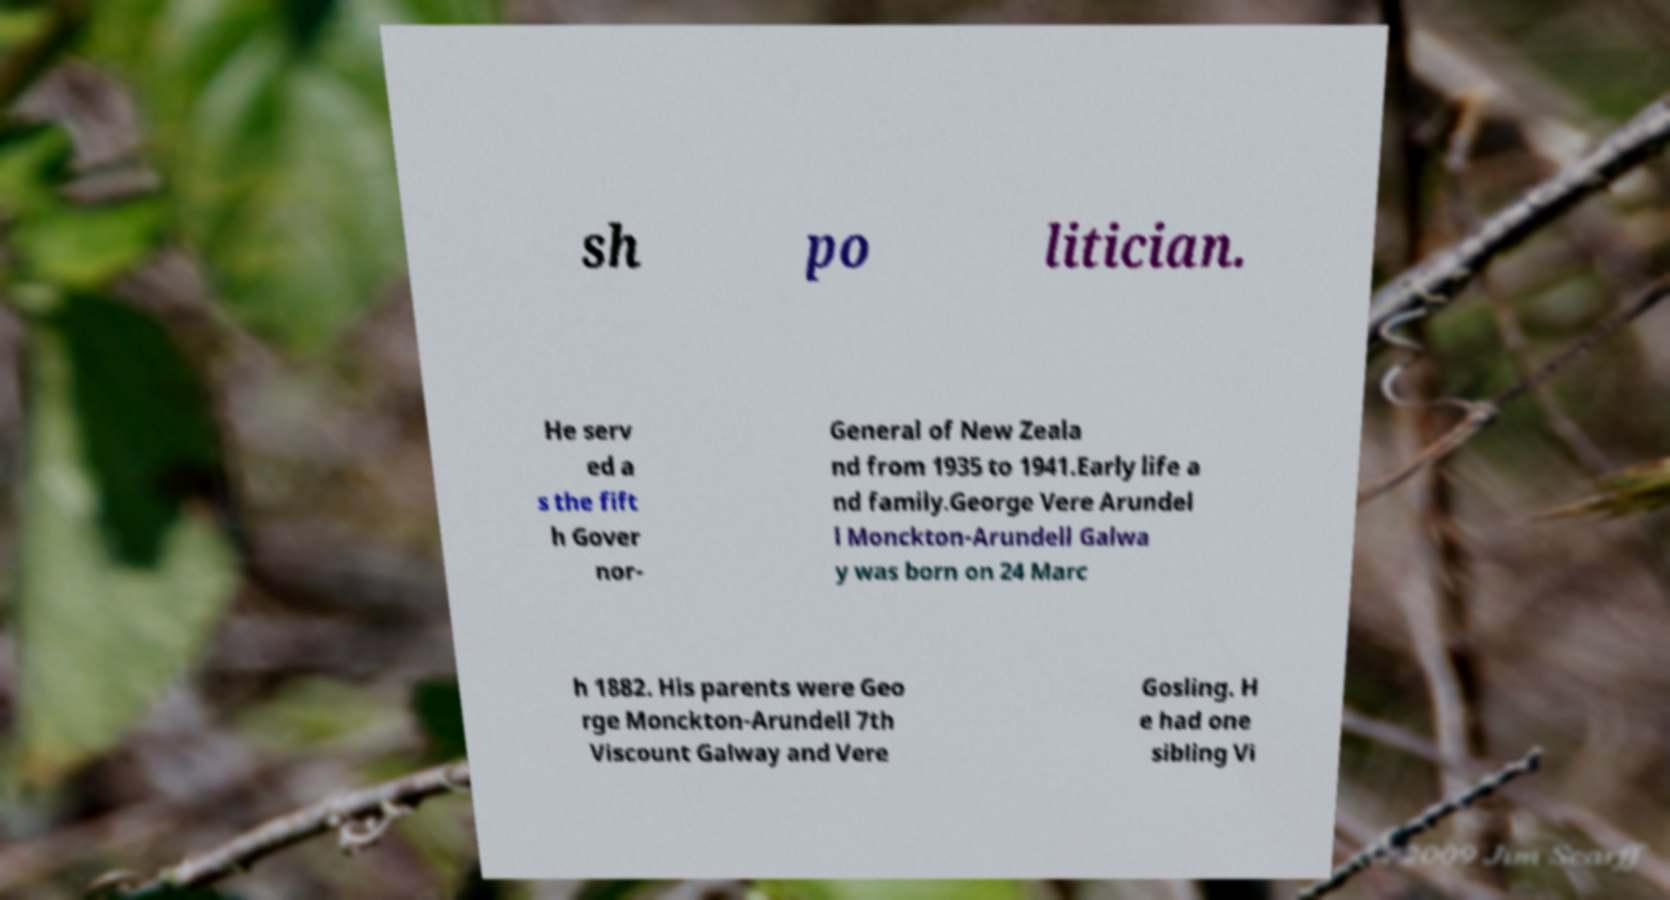Could you extract and type out the text from this image? sh po litician. He serv ed a s the fift h Gover nor- General of New Zeala nd from 1935 to 1941.Early life a nd family.George Vere Arundel l Monckton-Arundell Galwa y was born on 24 Marc h 1882. His parents were Geo rge Monckton-Arundell 7th Viscount Galway and Vere Gosling. H e had one sibling Vi 